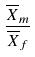Convert formula to latex. <formula><loc_0><loc_0><loc_500><loc_500>\frac { \overline { X } _ { m } } { \overline { X } _ { f } }</formula> 